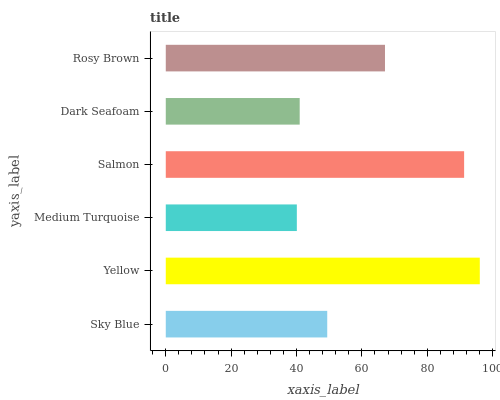Is Medium Turquoise the minimum?
Answer yes or no. Yes. Is Yellow the maximum?
Answer yes or no. Yes. Is Yellow the minimum?
Answer yes or no. No. Is Medium Turquoise the maximum?
Answer yes or no. No. Is Yellow greater than Medium Turquoise?
Answer yes or no. Yes. Is Medium Turquoise less than Yellow?
Answer yes or no. Yes. Is Medium Turquoise greater than Yellow?
Answer yes or no. No. Is Yellow less than Medium Turquoise?
Answer yes or no. No. Is Rosy Brown the high median?
Answer yes or no. Yes. Is Sky Blue the low median?
Answer yes or no. Yes. Is Sky Blue the high median?
Answer yes or no. No. Is Dark Seafoam the low median?
Answer yes or no. No. 